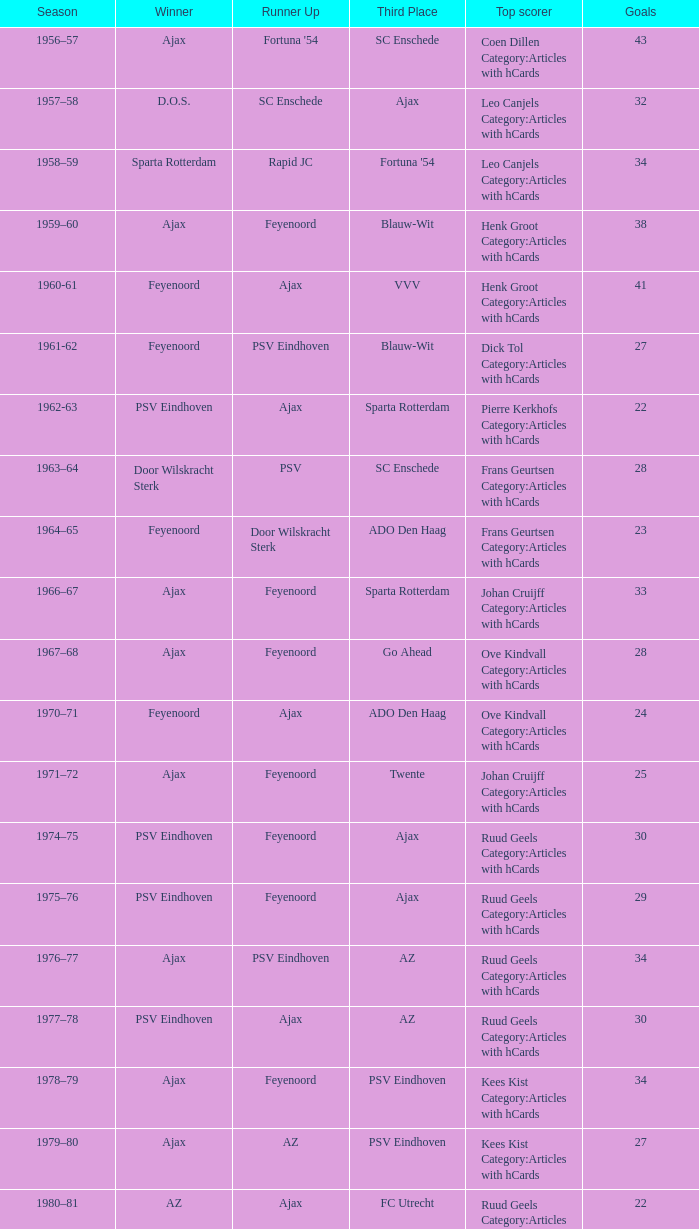Could you parse the entire table as a dict? {'header': ['Season', 'Winner', 'Runner Up', 'Third Place', 'Top scorer', 'Goals'], 'rows': [['1956–57', 'Ajax', "Fortuna '54", 'SC Enschede', 'Coen Dillen Category:Articles with hCards', '43'], ['1957–58', 'D.O.S.', 'SC Enschede', 'Ajax', 'Leo Canjels Category:Articles with hCards', '32'], ['1958–59', 'Sparta Rotterdam', 'Rapid JC', "Fortuna '54", 'Leo Canjels Category:Articles with hCards', '34'], ['1959–60', 'Ajax', 'Feyenoord', 'Blauw-Wit', 'Henk Groot Category:Articles with hCards', '38'], ['1960-61', 'Feyenoord', 'Ajax', 'VVV', 'Henk Groot Category:Articles with hCards', '41'], ['1961-62', 'Feyenoord', 'PSV Eindhoven', 'Blauw-Wit', 'Dick Tol Category:Articles with hCards', '27'], ['1962-63', 'PSV Eindhoven', 'Ajax', 'Sparta Rotterdam', 'Pierre Kerkhofs Category:Articles with hCards', '22'], ['1963–64', 'Door Wilskracht Sterk', 'PSV', 'SC Enschede', 'Frans Geurtsen Category:Articles with hCards', '28'], ['1964–65', 'Feyenoord', 'Door Wilskracht Sterk', 'ADO Den Haag', 'Frans Geurtsen Category:Articles with hCards', '23'], ['1966–67', 'Ajax', 'Feyenoord', 'Sparta Rotterdam', 'Johan Cruijff Category:Articles with hCards', '33'], ['1967–68', 'Ajax', 'Feyenoord', 'Go Ahead', 'Ove Kindvall Category:Articles with hCards', '28'], ['1970–71', 'Feyenoord', 'Ajax', 'ADO Den Haag', 'Ove Kindvall Category:Articles with hCards', '24'], ['1971–72', 'Ajax', 'Feyenoord', 'Twente', 'Johan Cruijff Category:Articles with hCards', '25'], ['1974–75', 'PSV Eindhoven', 'Feyenoord', 'Ajax', 'Ruud Geels Category:Articles with hCards', '30'], ['1975–76', 'PSV Eindhoven', 'Feyenoord', 'Ajax', 'Ruud Geels Category:Articles with hCards', '29'], ['1976–77', 'Ajax', 'PSV Eindhoven', 'AZ', 'Ruud Geels Category:Articles with hCards', '34'], ['1977–78', 'PSV Eindhoven', 'Ajax', 'AZ', 'Ruud Geels Category:Articles with hCards', '30'], ['1978–79', 'Ajax', 'Feyenoord', 'PSV Eindhoven', 'Kees Kist Category:Articles with hCards', '34'], ['1979–80', 'Ajax', 'AZ', 'PSV Eindhoven', 'Kees Kist Category:Articles with hCards', '27'], ['1980–81', 'AZ', 'Ajax', 'FC Utrecht', 'Ruud Geels Category:Articles with hCards', '22'], ['1981-82', 'Ajax', 'PSV Eindhoven', 'AZ', 'Wim Kieft Category:Articles with hCards', '32'], ['1982-83', 'Ajax', 'Feyenoord', 'PSV Eindhoven', 'Peter Houtman Category:Articles with hCards', '30'], ['1983-84', 'Feyenoord', 'PSV Eindhoven', 'Ajax', 'Marco van Basten Category:Articles with hCards', '28'], ['1984-85', 'Ajax', 'PSV Eindhoven', 'Feyenoord', 'Marco van Basten Category:Articles with hCards', '22'], ['1985-86', 'PSV Eindhoven', 'Ajax', 'Feyenoord', 'Marco van Basten Category:Articles with hCards', '37'], ['1986-87', 'PSV Eindhoven', 'Ajax', 'Feyenoord', 'Marco van Basten Category:Articles with hCards', '31'], ['1987-88', 'PSV Eindhoven', 'Ajax', 'Twente', 'Wim Kieft Category:Articles with hCards', '29'], ['1988–89', 'PSV Eindhoven', 'Ajax', 'Twente', 'Romário', '19'], ['1989-90', 'Ajax', 'PSV Eindhoven', 'Twente', 'Romário', '23'], ['1990–91', 'PSV Eindhoven', 'Ajax', 'FC Groningen', 'Romário Dennis Bergkamp', '25'], ['1991–92', 'PSV Eindhoven', 'Ajax', 'Feyenoord', 'Dennis Bergkamp Category:Articles with hCards', '22'], ['1992–93', 'Feyenoord', 'PSV Eindhoven', 'Ajax', 'Dennis Bergkamp Category:Articles with hCards', '26'], ['1993–94', 'Ajax', 'Feyenoord', 'PSV Eindhoven', 'Jari Litmanen Category:Articles with hCards', '26'], ['1994–95', 'Ajax', 'Roda JC', 'PSV Eindhoven', 'Ronaldo', '30'], ['1995–96', 'Ajax', 'PSV Eindhoven', 'Feyenoord', 'Luc Nilis Category:Articles with hCards', '21'], ['1996–97', 'PSV Eindhoven', 'Feyenoord', 'Twente', 'Luc Nilis Category:Articles with hCards', '21'], ['1997–98', 'Ajax', 'PSV Eindhoven', 'Vitesse', 'Nikos Machlas Category:Articles with hCards', '34'], ['1998–99', 'Feyenoord', 'Willem II', 'PSV Eindhoven', 'Ruud van Nistelrooy Category:Articles with hCards', '31'], ['1999–2000', 'PSV Eindhoven', 'Heerenveen', 'Feyenoord', 'Ruud van Nistelrooy Category:Articles with hCards', '29'], ['2000–01', 'PSV Eindhoven', 'Feyenoord', 'Ajax', 'Mateja Kežman Category:Articles with hCards', '24'], ['2001–02', 'Ajax', 'PSV Eindhoven', 'Feyenoord', 'Pierre van Hooijdonk Category:Articles with hCards', '24'], ['2002-03', 'PSV Eindhoven', 'Ajax', 'Feyenoord', 'Mateja Kežman Category:Articles with hCards', '35'], ['2003-04', 'Ajax', 'PSV Eindhoven', 'Feyenoord', 'Mateja Kežman Category:Articles with hCards', '31'], ['2004-05', 'PSV Eindhoven', 'Ajax', 'AZ', 'Dirk Kuyt Category:Articles with hCards', '29'], ['2005-06', 'PSV Eindhoven', 'AZ', 'Feyenoord', 'Klaas-Jan Huntelaar Category:Articles with hCards', '33'], ['2006-07', 'PSV Eindhoven', 'Ajax', 'AZ', 'Afonso Alves Category:Articles with hCards', '34'], ['2007-08', 'PSV Eindhoven', 'Ajax', 'NAC Breda', 'Klaas-Jan Huntelaar Category:Articles with hCards', '33'], ['2008-09', 'AZ', 'Twente', 'Ajax', 'Mounir El Hamdaoui Category:Articles with hCards', '23'], ['2009-10', 'Twente', 'Ajax', 'PSV Eindhoven', 'Luis Suárez Category:Articles with hCards', '35'], ['2010-11', 'Ajax', 'Twente', 'PSV Eindhoven', 'Björn Vleminckx Category:Articles with hCards', '23'], ['2011-12', 'Ajax', 'Feyenoord', 'PSV Eindhoven', 'Bas Dost Category:Articles with hCards', '32']]} When az is the second-place finisher and feyenoord takes third, how many total winners are there? 1.0. 